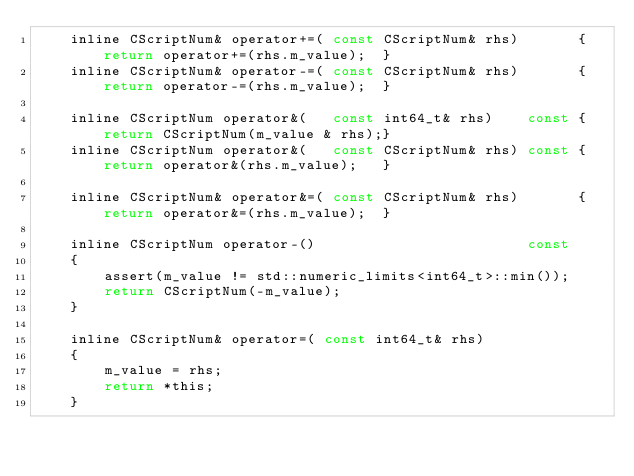<code> <loc_0><loc_0><loc_500><loc_500><_C_>    inline CScriptNum& operator+=( const CScriptNum& rhs)       { return operator+=(rhs.m_value);  }
    inline CScriptNum& operator-=( const CScriptNum& rhs)       { return operator-=(rhs.m_value);  }

    inline CScriptNum operator&(   const int64_t& rhs)    const { return CScriptNum(m_value & rhs);}
    inline CScriptNum operator&(   const CScriptNum& rhs) const { return operator&(rhs.m_value);   }

    inline CScriptNum& operator&=( const CScriptNum& rhs)       { return operator&=(rhs.m_value);  }

    inline CScriptNum operator-()                         const
    {
        assert(m_value != std::numeric_limits<int64_t>::min());
        return CScriptNum(-m_value);
    }

    inline CScriptNum& operator=( const int64_t& rhs)
    {
        m_value = rhs;
        return *this;
    }
</code> 